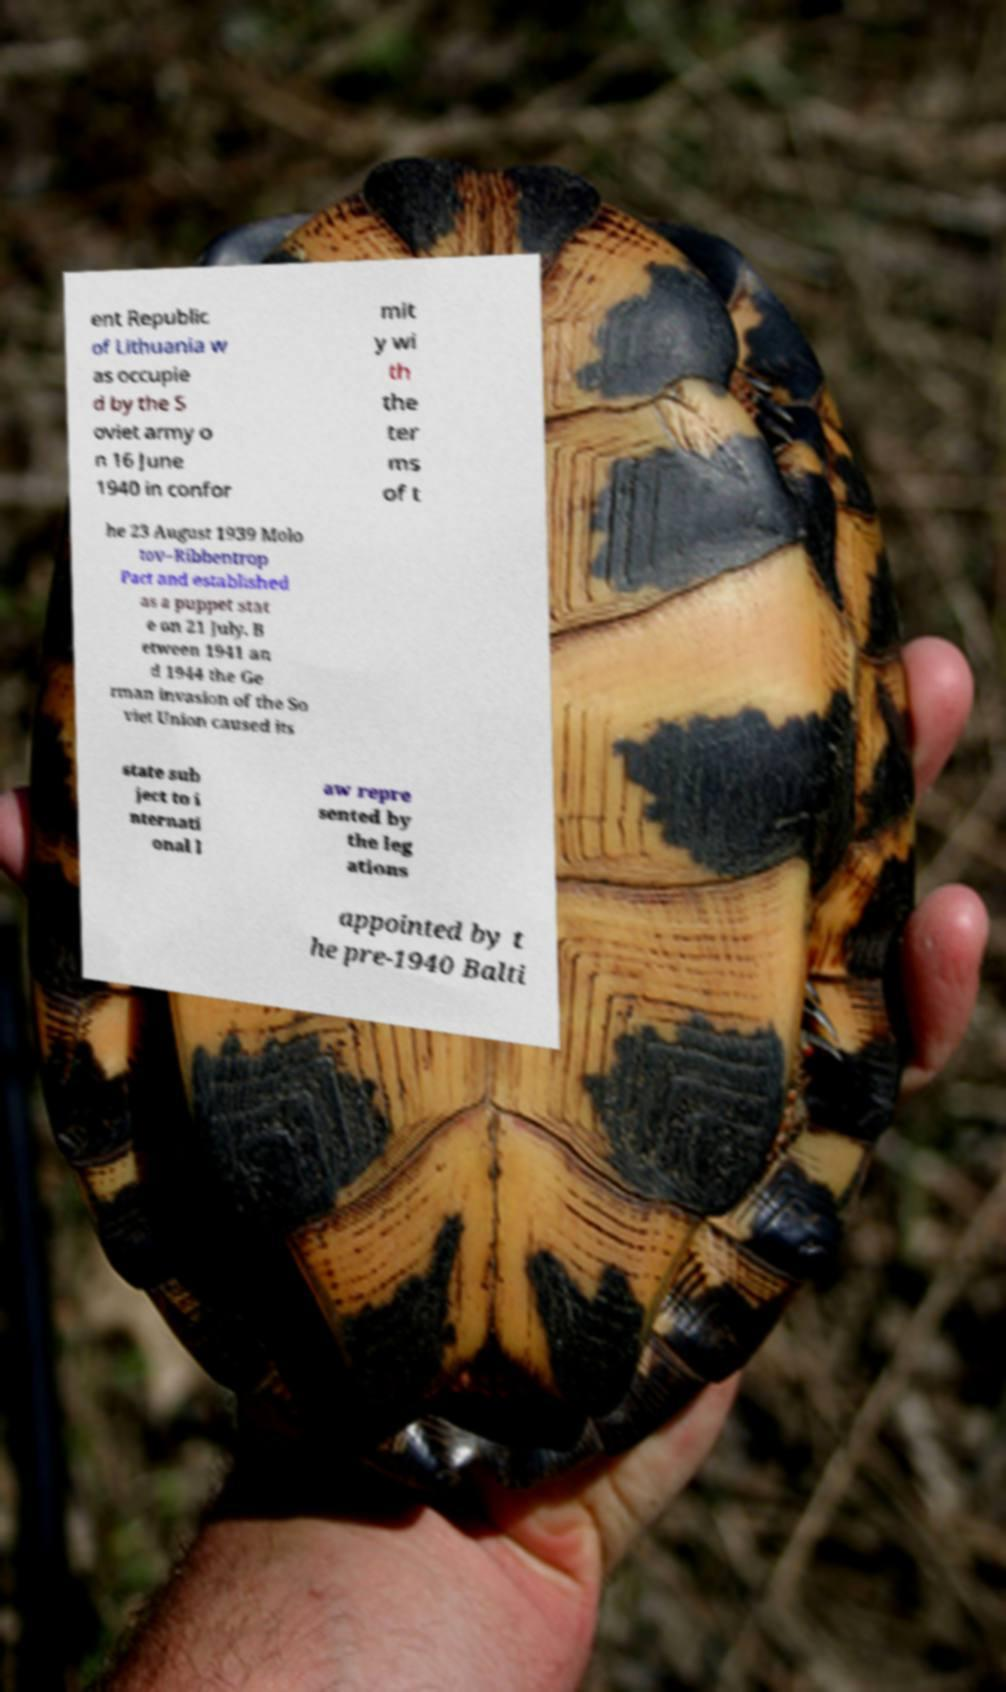Please identify and transcribe the text found in this image. ent Republic of Lithuania w as occupie d by the S oviet army o n 16 June 1940 in confor mit y wi th the ter ms of t he 23 August 1939 Molo tov–Ribbentrop Pact and established as a puppet stat e on 21 July. B etween 1941 an d 1944 the Ge rman invasion of the So viet Union caused its state sub ject to i nternati onal l aw repre sented by the leg ations appointed by t he pre-1940 Balti 